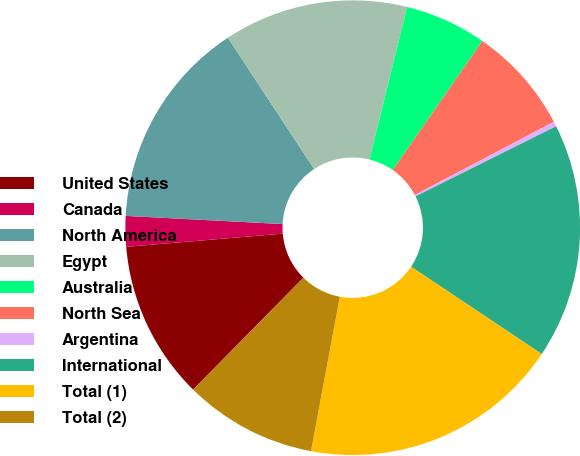<chart> <loc_0><loc_0><loc_500><loc_500><pie_chart><fcel>United States<fcel>Canada<fcel>North America<fcel>Egypt<fcel>Australia<fcel>North Sea<fcel>Argentina<fcel>International<fcel>Total (1)<fcel>Total (2)<nl><fcel>11.27%<fcel>2.17%<fcel>14.92%<fcel>13.1%<fcel>5.81%<fcel>7.63%<fcel>0.35%<fcel>16.74%<fcel>18.56%<fcel>9.45%<nl></chart> 